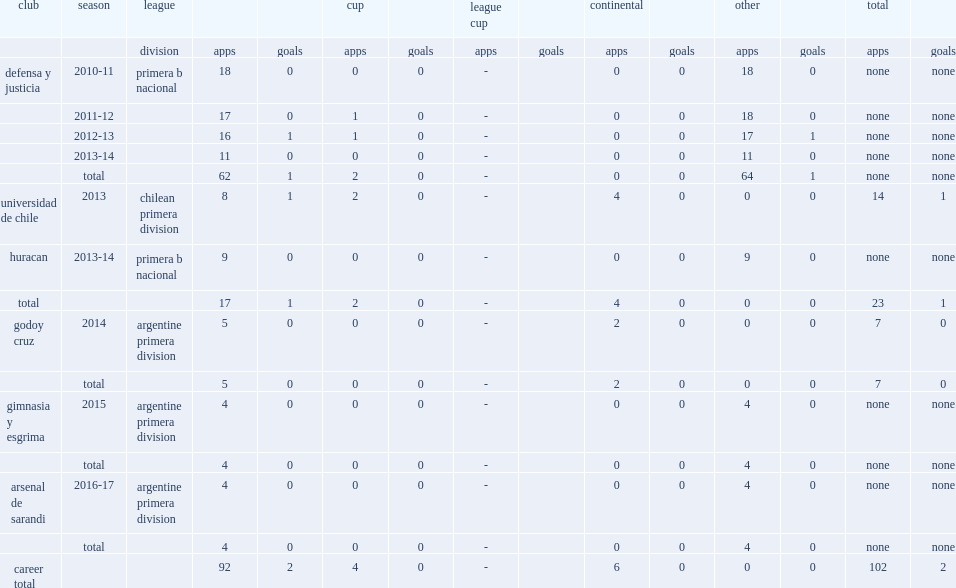Which league did sergio velazquez, join arsenal de sarandi's in the 2016-17 season? Argentine primera division. 